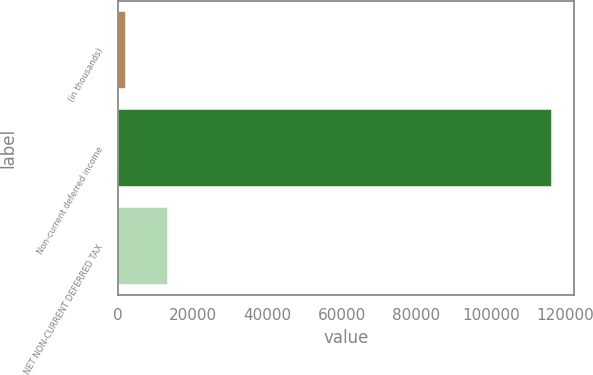Convert chart. <chart><loc_0><loc_0><loc_500><loc_500><bar_chart><fcel>(in thousands)<fcel>Non-current deferred income<fcel>NET NON-CURRENT DEFERRED TAX<nl><fcel>2011<fcel>116432<fcel>13453.1<nl></chart> 